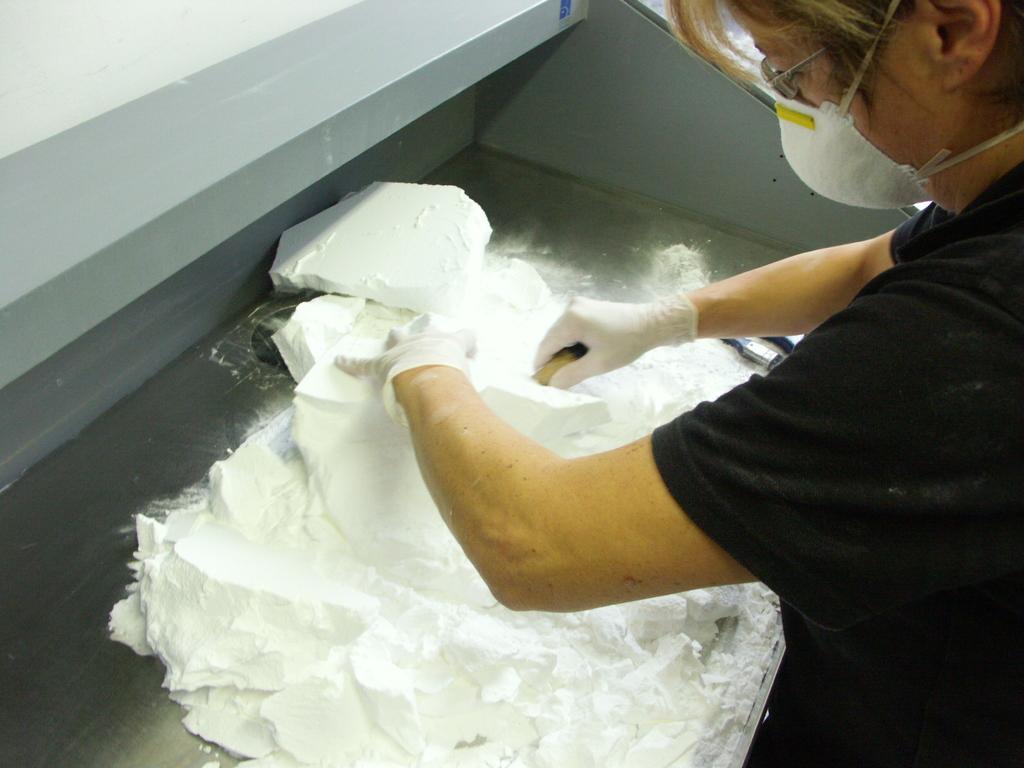Could you give a brief overview of what you see in this image? In this image there is a person wearing gloves and a mask is holding the blocks of white colored powder on a metal platform. 